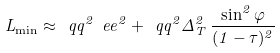<formula> <loc_0><loc_0><loc_500><loc_500>L _ { \min } \approx \ q q ^ { 2 } \ e e ^ { 2 } + \ q q ^ { 2 } \Delta _ { T } ^ { 2 } \, \frac { \sin ^ { 2 } \varphi } { ( 1 - \tau ) ^ { 2 } }</formula> 